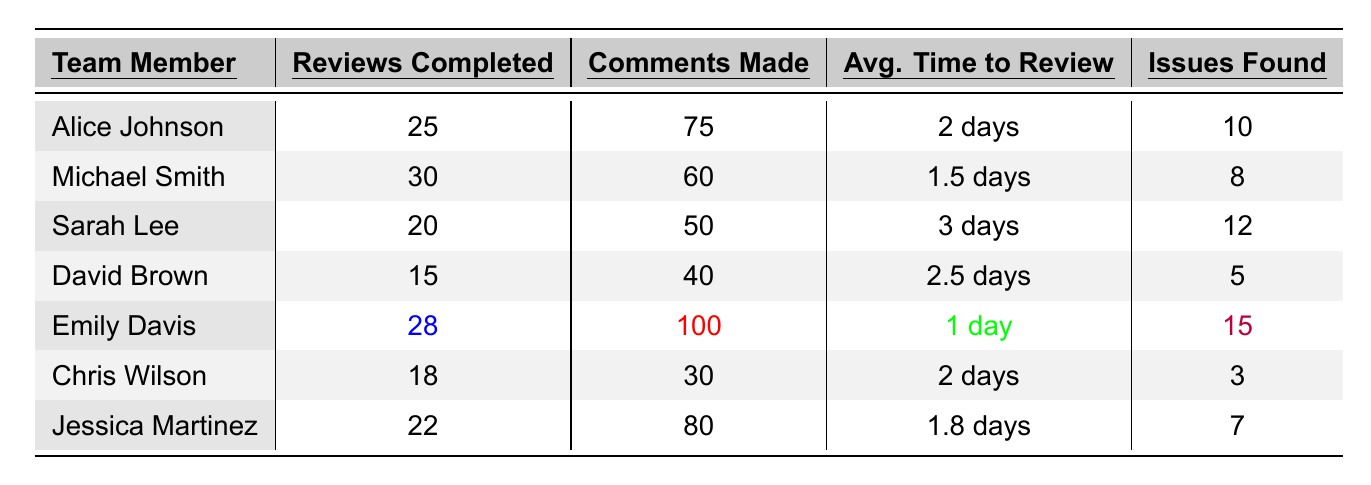What is the maximum number of reviews completed by a team member? By looking at the "Reviews Completed" column, the maximum value is 30, which corresponds to Michael Smith.
Answer: 30 Who made the highest number of comments during code reviews? The "Comments Made" column shows that Emily Davis has the highest count at 100.
Answer: 100 What was the average time to review for Sarah Lee? The "Avg. Time to Review" column indicates that Sarah Lee took 3 days on average.
Answer: 3 days Which team member found the least number of issues? The "Issues Found" column shows that David Brown found 5 issues, the lowest among all team members.
Answer: David Brown How many total reviews were completed by all team members? Summing the "Reviews Completed" column: 25 + 30 + 20 + 15 + 28 + 18 + 22 = 168.
Answer: 168 What is the average number of comments made by all team members? Calculating the average: (75 + 60 + 50 + 40 + 100 + 30 + 80) / 7 = 59.29, rounded to 59.
Answer: 59 Is Emily Davis's average time to review less than 2 days? Emily Davis has an average time to review of 1 day, which is indeed less than 2 days.
Answer: Yes Who completed more reviews, Alice Johnson or Chris Wilson? Alice Johnson completed 25 reviews, while Chris Wilson completed 18, thus Alice Johnson completed more.
Answer: Alice Johnson If we consider only the team members who completed 20 or more reviews, what is their average number of issues found? The qualifying team members are Alice Johnson (10), Michael Smith (8), Emily Davis (15), and Jessica Martinez (7) with a total of 10 + 8 + 15 + 7 = 40 and 4 members, leading to an average of 40 / 4 = 10.
Answer: 10 Which team member took the longest on average to complete a review? The "Avg. Time to Review" column shows Sarah Lee took the longest at 3 days, compared to all other team members.
Answer: Sarah Lee 